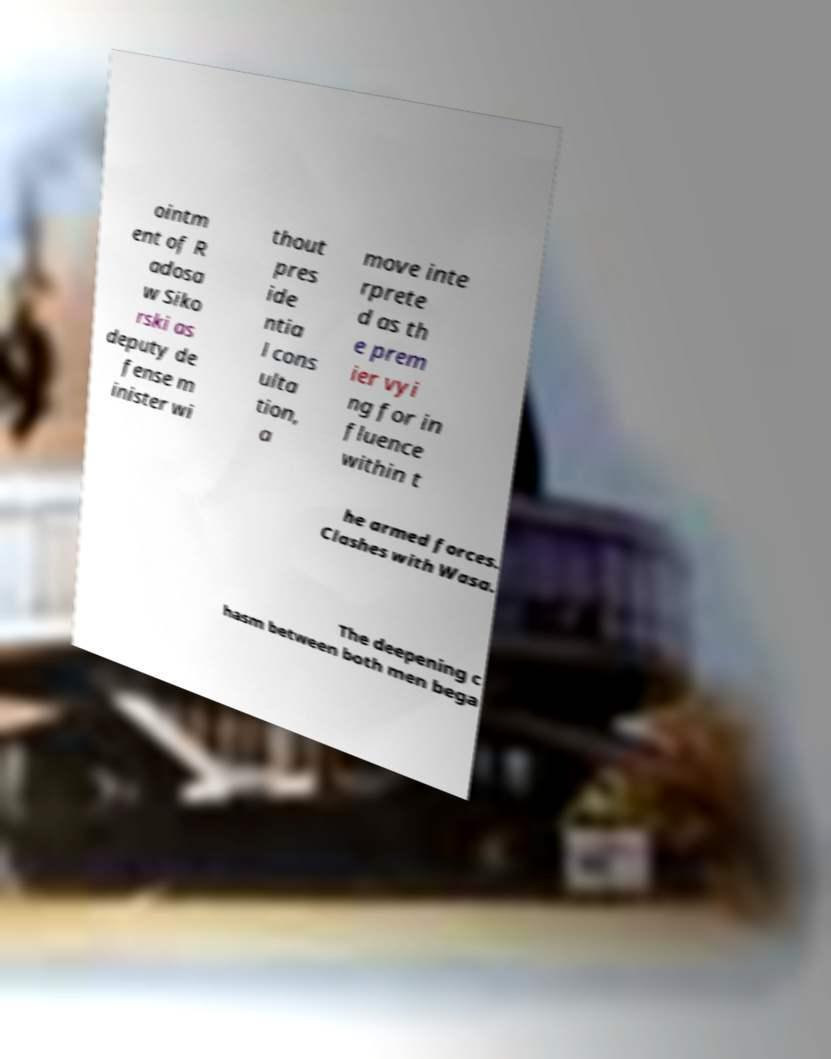There's text embedded in this image that I need extracted. Can you transcribe it verbatim? ointm ent of R adosa w Siko rski as deputy de fense m inister wi thout pres ide ntia l cons ulta tion, a move inte rprete d as th e prem ier vyi ng for in fluence within t he armed forces. Clashes with Wasa. The deepening c hasm between both men bega 